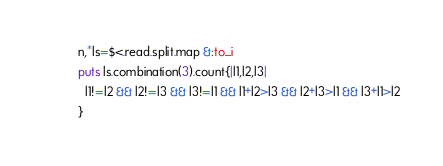<code> <loc_0><loc_0><loc_500><loc_500><_Ruby_>n,*ls=$<.read.split.map &:to_i
puts ls.combination(3).count{|l1,l2,l3|
  l1!=l2 && l2!=l3 && l3!=l1 && l1+l2>l3 && l2+l3>l1 && l3+l1>l2
}</code> 